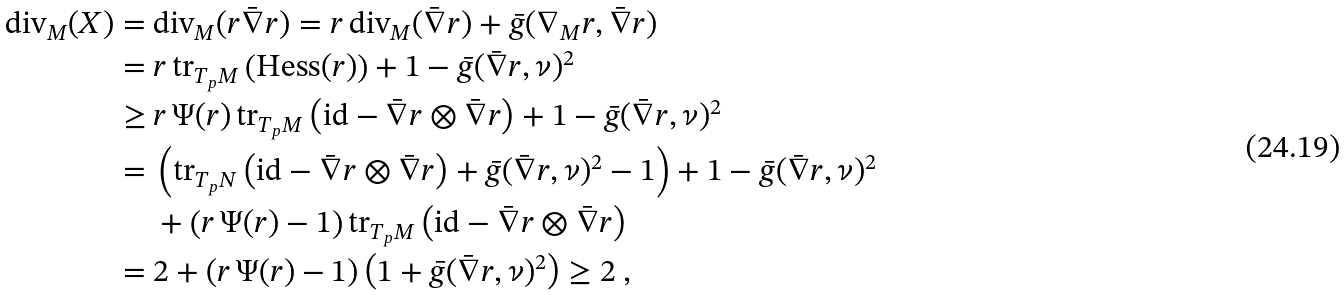Convert formula to latex. <formula><loc_0><loc_0><loc_500><loc_500>\text {div} _ { M } ( X ) = & \ \text {div} _ { M } ( r \bar { \nabla } r ) = r \, \text {div} _ { M } ( \bar { \nabla } r ) + \bar { g } ( \nabla _ { M } r , \bar { \nabla } r ) \\ = & \ r \, \text {tr} _ { T _ { p } M } \left ( \text {Hess} ( r ) \right ) + 1 - \bar { g } ( \bar { \nabla } r , \nu ) ^ { 2 } \\ \geq & \ r \, \Psi ( r ) \, \text {tr} _ { T _ { p } M } \left ( \text {id} - \bar { \nabla } r \otimes \bar { \nabla } r \right ) + 1 - \bar { g } ( \bar { \nabla } r , \nu ) ^ { 2 } \\ = & \ \left ( \text {tr} _ { T _ { p } N } \left ( \text {id} - \bar { \nabla } r \otimes \bar { \nabla } r \right ) + \bar { g } ( \bar { \nabla } r , \nu ) ^ { 2 } - 1 \right ) + 1 - \bar { g } ( \bar { \nabla } r , \nu ) ^ { 2 } \\ & \ + \left ( r \, \Psi ( r ) - 1 \right ) \text {tr} _ { T _ { p } M } \left ( \text {id} - \bar { \nabla } r \otimes \bar { \nabla } r \right ) \\ = & \ 2 + \left ( r \, \Psi ( r ) - 1 \right ) \left ( 1 + \bar { g } ( \bar { \nabla } r , \nu ) ^ { 2 } \right ) \geq 2 \ ,</formula> 